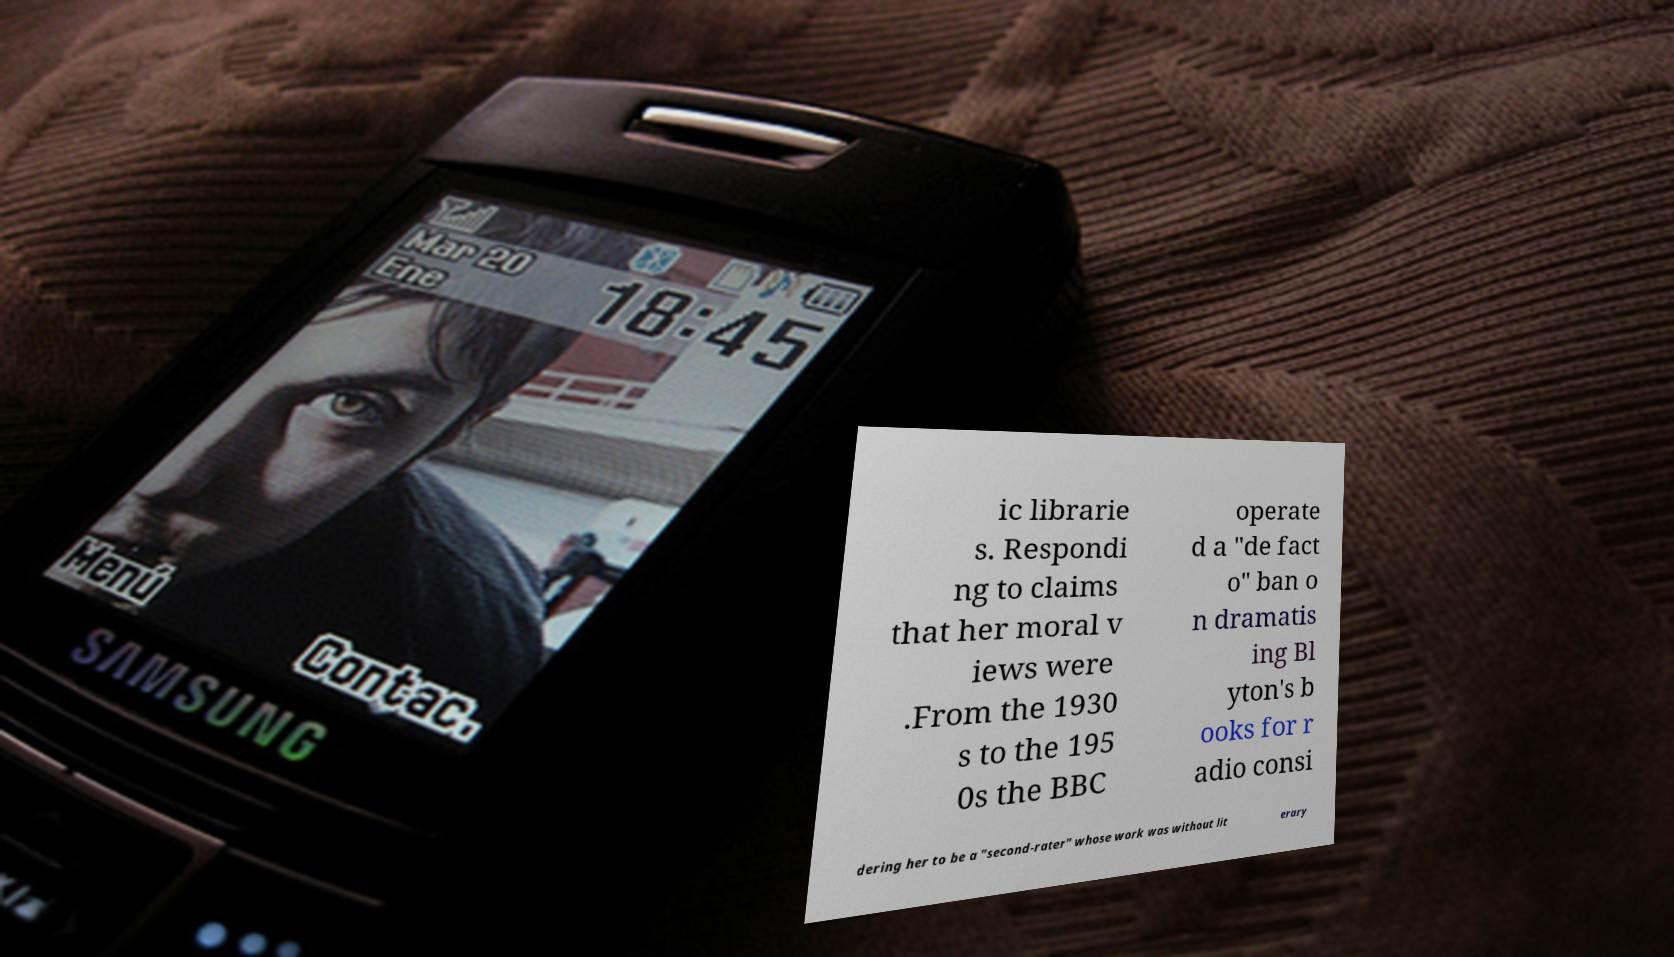Could you extract and type out the text from this image? ic librarie s. Respondi ng to claims that her moral v iews were .From the 1930 s to the 195 0s the BBC operate d a "de fact o" ban o n dramatis ing Bl yton's b ooks for r adio consi dering her to be a "second-rater" whose work was without lit erary 